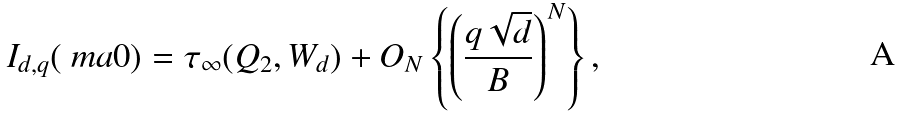Convert formula to latex. <formula><loc_0><loc_0><loc_500><loc_500>I _ { d , q } ( \ m a { 0 } ) = \tau _ { \infty } ( Q _ { 2 } , W _ { d } ) + O _ { N } \left \{ \left ( \frac { q \sqrt { d } } { B } \right ) ^ { N } \right \} ,</formula> 